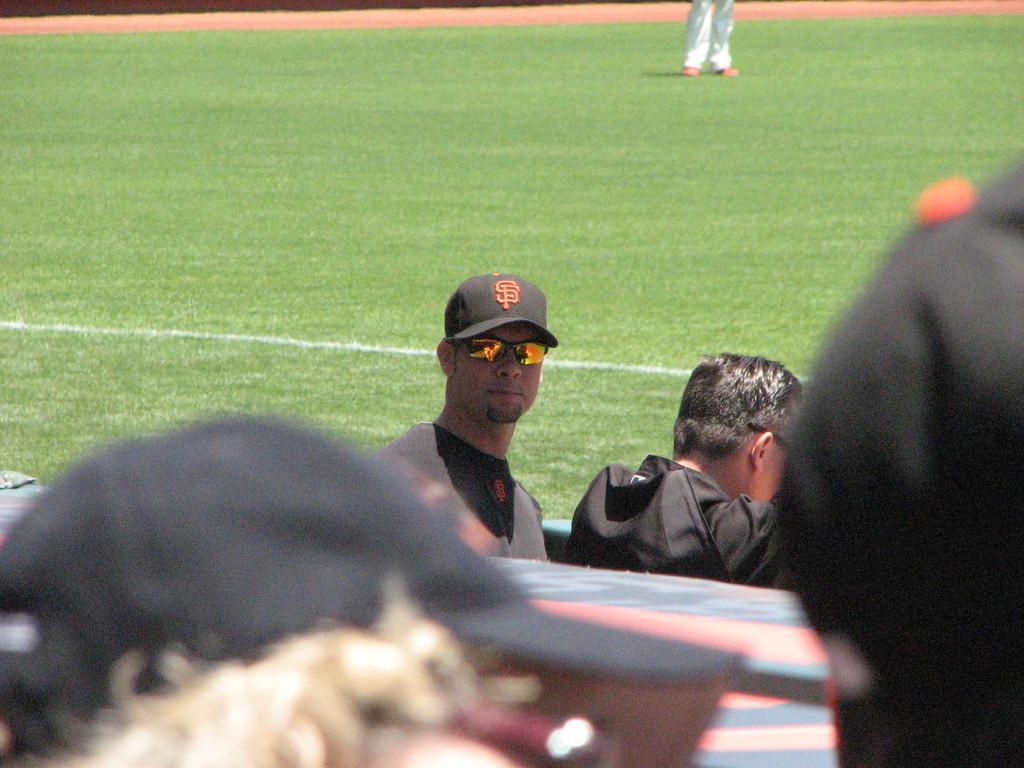Can you describe this image briefly? In the middle a man is looking at his side, he wore t-shirt, spectacles, cap. This is the ground. 